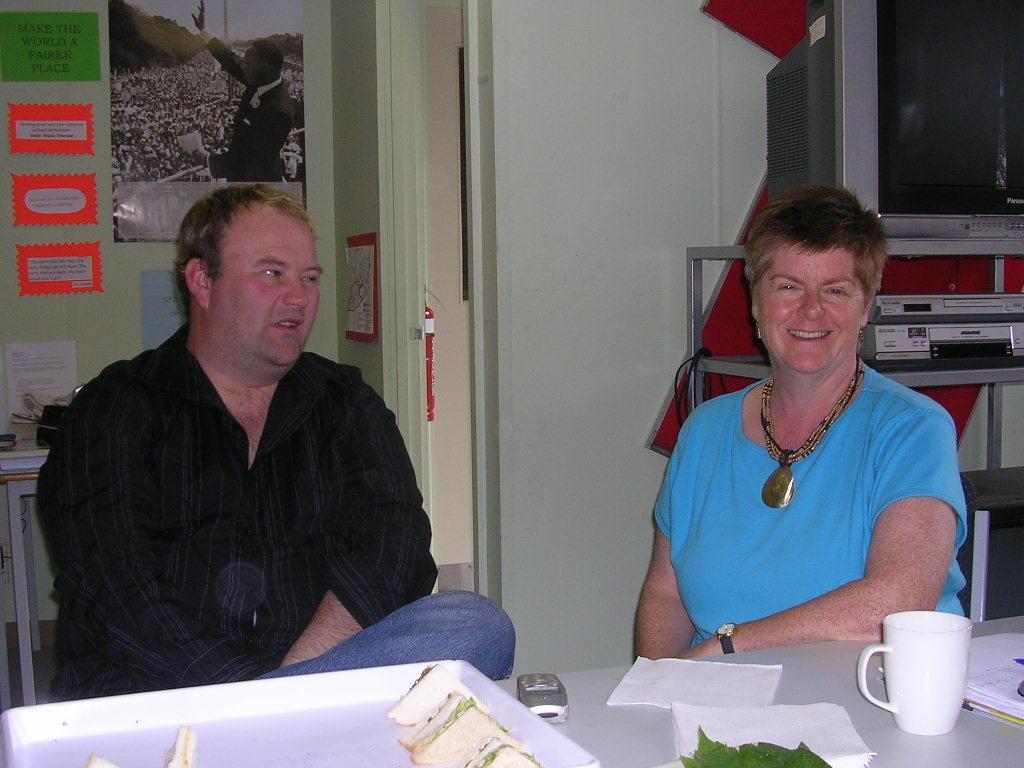Can you describe this image briefly? This Image is clicked inside a room where it has a woman on the right side and man on the left side. Women wore blue color t-shirt and Chain men wore black colour shirt and jeans ,there are so many papers pasted on the left side. There is television in the top right corner ,there is a cup on the bottom right corner. There is a plate placed in front of a man in the bottom it has sandwiches in it, there is also a phone placed in the bottom. There is a table in front of them there are tissues in the bottom on the table. 